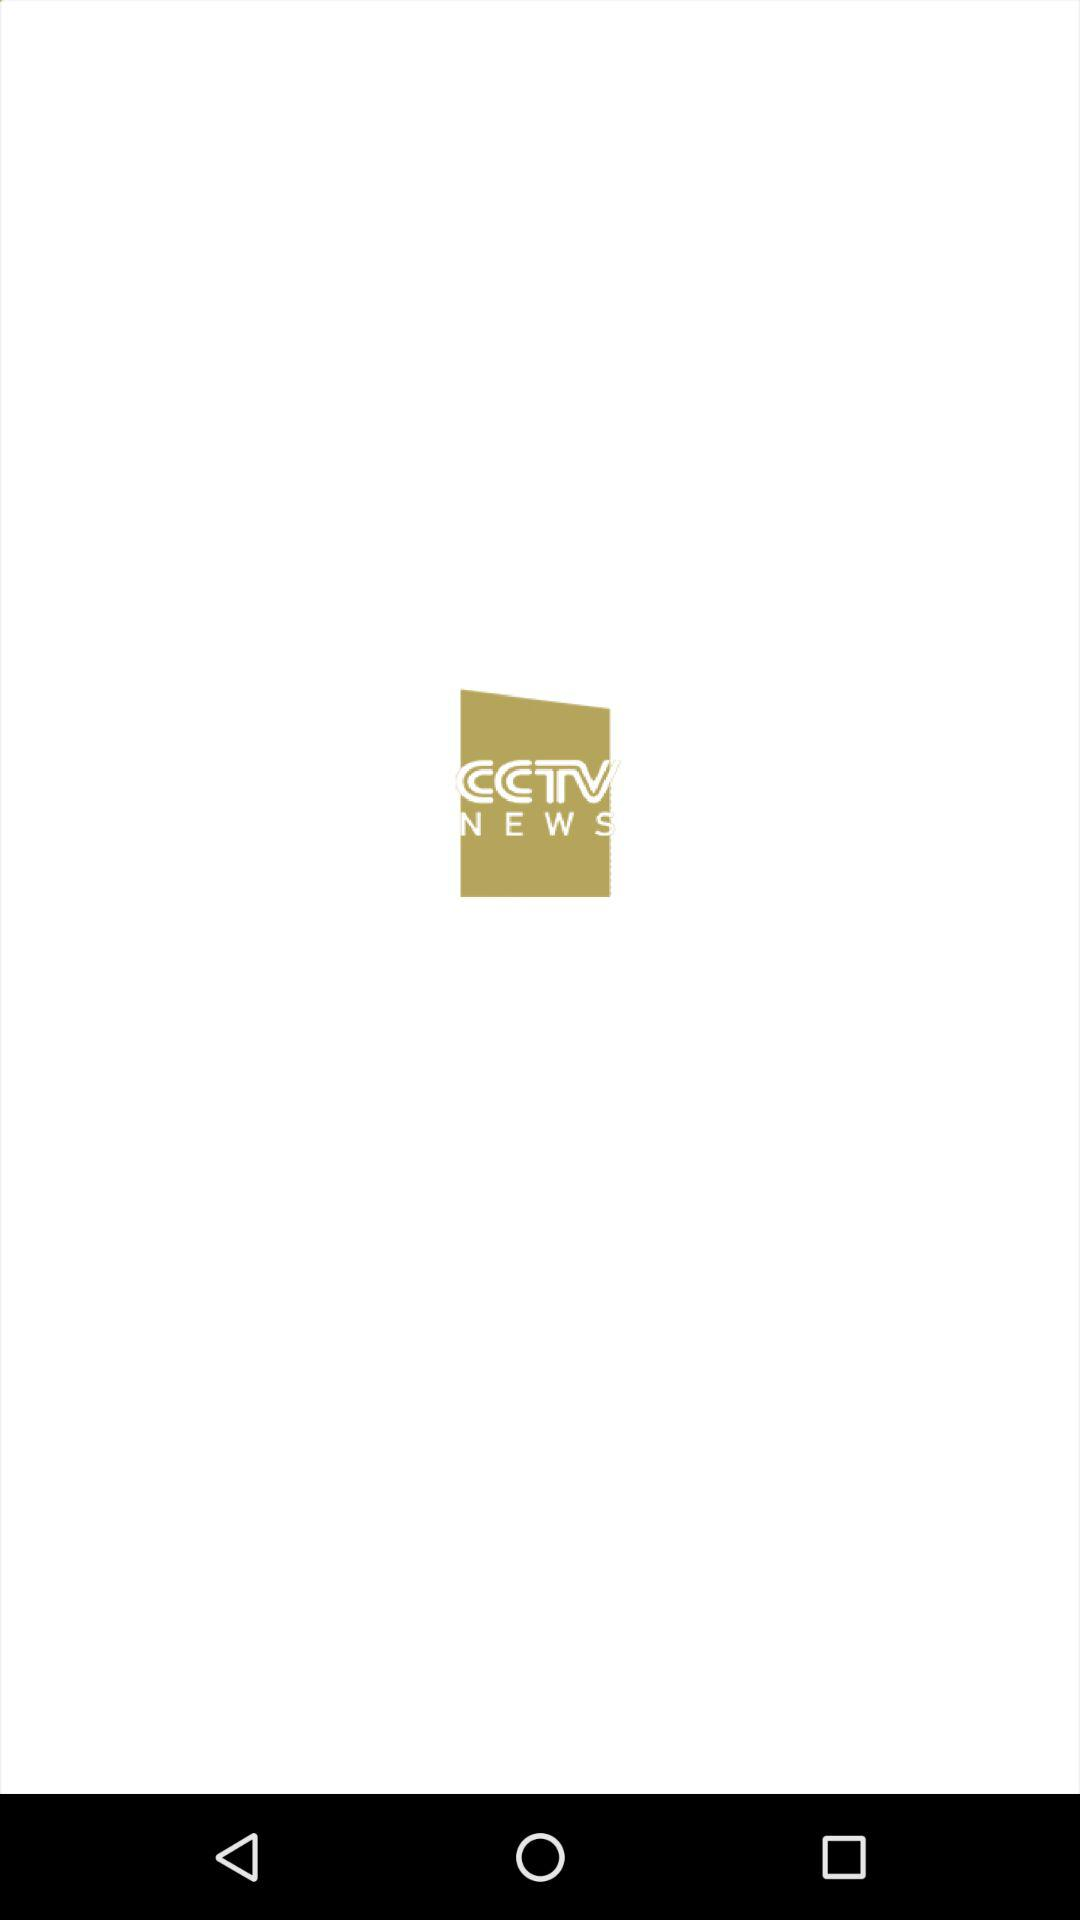What is the application name? The application name is "CCTV NEWS". 